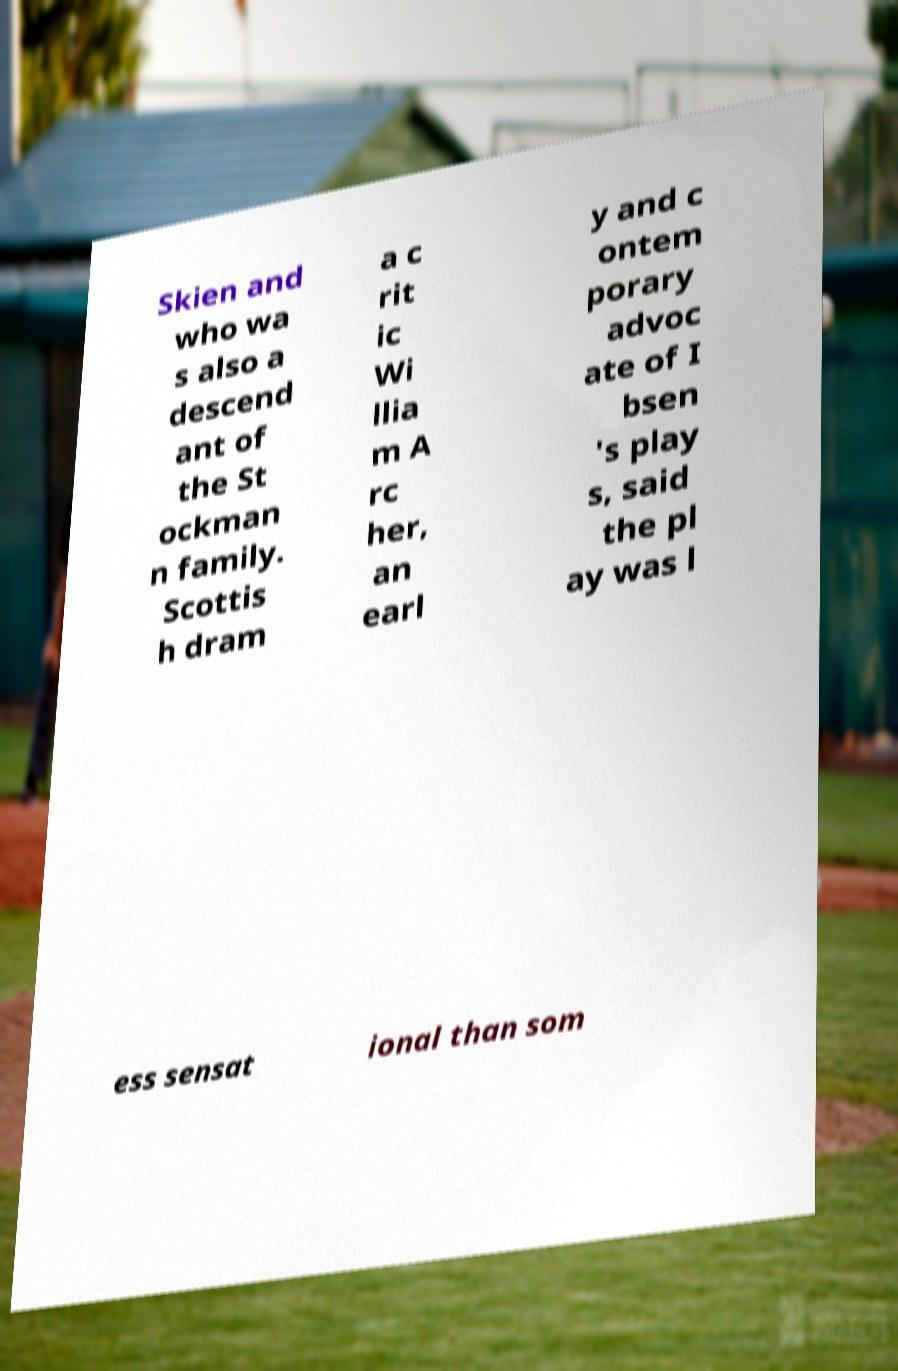Can you accurately transcribe the text from the provided image for me? Skien and who wa s also a descend ant of the St ockman n family. Scottis h dram a c rit ic Wi llia m A rc her, an earl y and c ontem porary advoc ate of I bsen 's play s, said the pl ay was l ess sensat ional than som 